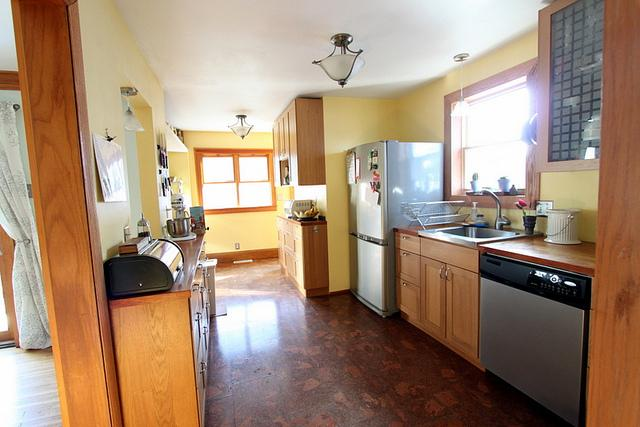What is the rolltop object used for? Please explain your reasoning. bread box. The box is used to store bread. 